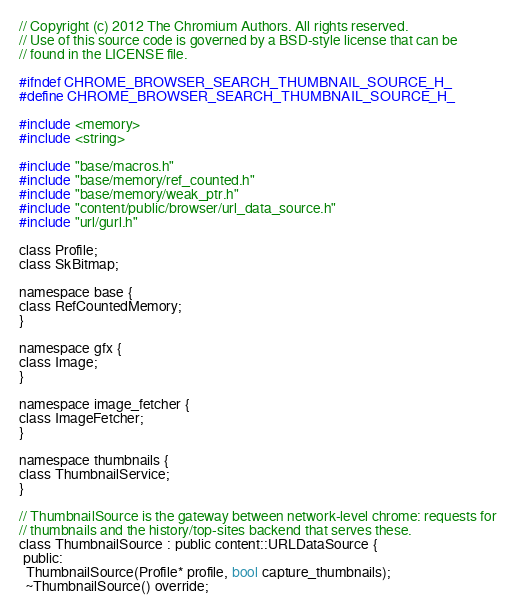Convert code to text. <code><loc_0><loc_0><loc_500><loc_500><_C_>// Copyright (c) 2012 The Chromium Authors. All rights reserved.
// Use of this source code is governed by a BSD-style license that can be
// found in the LICENSE file.

#ifndef CHROME_BROWSER_SEARCH_THUMBNAIL_SOURCE_H_
#define CHROME_BROWSER_SEARCH_THUMBNAIL_SOURCE_H_

#include <memory>
#include <string>

#include "base/macros.h"
#include "base/memory/ref_counted.h"
#include "base/memory/weak_ptr.h"
#include "content/public/browser/url_data_source.h"
#include "url/gurl.h"

class Profile;
class SkBitmap;

namespace base {
class RefCountedMemory;
}

namespace gfx {
class Image;
}

namespace image_fetcher {
class ImageFetcher;
}

namespace thumbnails {
class ThumbnailService;
}

// ThumbnailSource is the gateway between network-level chrome: requests for
// thumbnails and the history/top-sites backend that serves these.
class ThumbnailSource : public content::URLDataSource {
 public:
  ThumbnailSource(Profile* profile, bool capture_thumbnails);
  ~ThumbnailSource() override;
</code> 